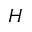<formula> <loc_0><loc_0><loc_500><loc_500>H</formula> 